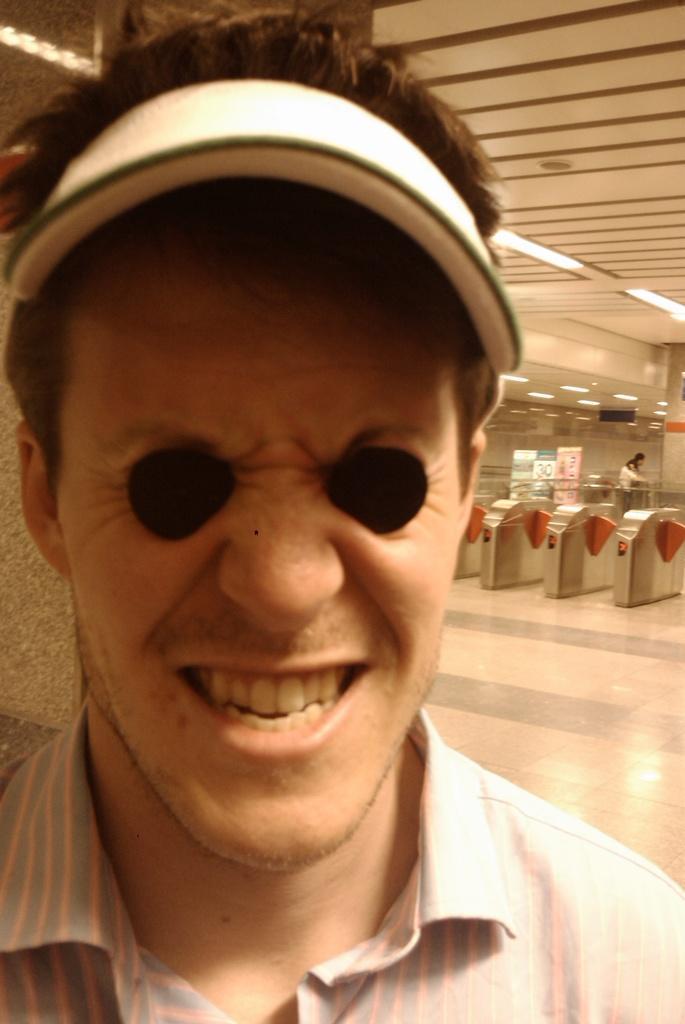Could you give a brief overview of what you see in this image? In this image I can see a man in the front and I can see he is wearing a cap. I can also see he is wearing a shirt. In the background of the image I can see few boards, two persons and few lights on the ceiling. I can also see something is written on these boards. 